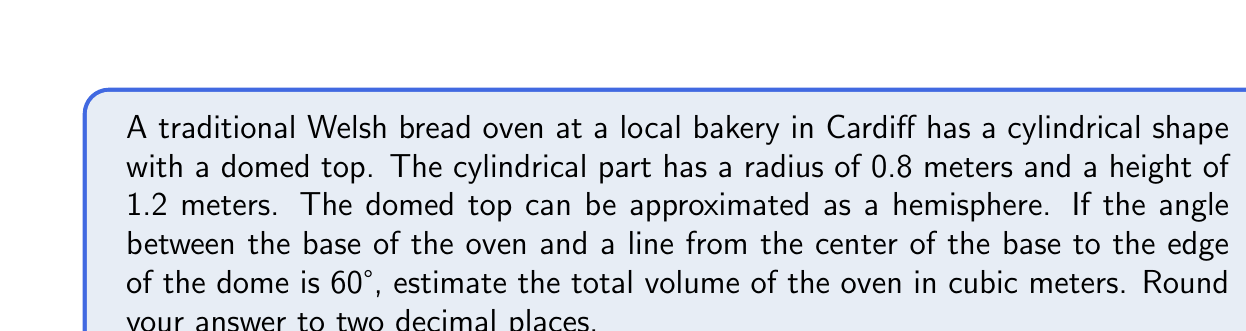Teach me how to tackle this problem. Let's approach this step-by-step:

1) First, let's calculate the volume of the cylindrical part:
   $$V_{cylinder} = \pi r^2 h = \pi (0.8)^2 (1.2) = 2.4128\pi$$

2) Now, we need to find the radius of the hemisphere. We can use trigonometry for this:
   $$\tan 60° = \frac{r}{1.2}$$
   $$r = 1.2 \tan 60° = 1.2 (\sqrt{3}) = 2.0785$$

3) The volume of a hemisphere is given by:
   $$V_{hemisphere} = \frac{2}{3}\pi r^3$$
   
   Substituting our value for r:
   $$V_{hemisphere} = \frac{2}{3}\pi (2.0785)^3 = 18.8739\pi$$

4) The total volume is the sum of the cylinder and hemisphere volumes:
   $$V_{total} = V_{cylinder} + V_{hemisphere}$$
   $$V_{total} = 2.4128\pi + 18.8739\pi = 21.2867\pi$$

5) Evaluating this and rounding to two decimal places:
   $$V_{total} = 66.85 \text{ cubic meters}$$
Answer: 66.85 m³ 